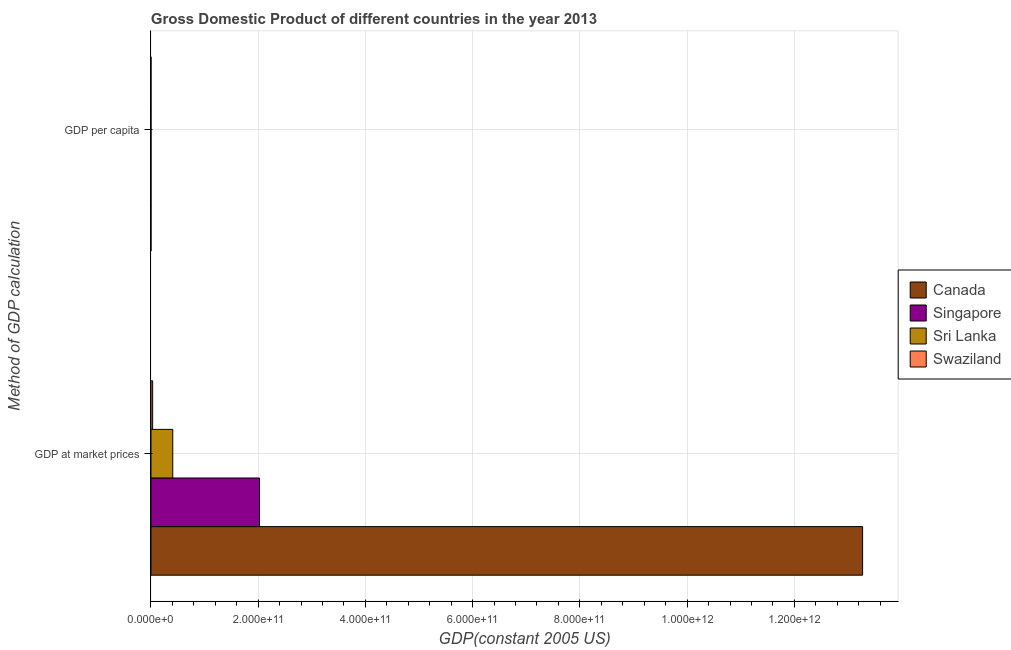How many groups of bars are there?
Your response must be concise. 2. Are the number of bars per tick equal to the number of legend labels?
Your answer should be compact. Yes. How many bars are there on the 1st tick from the top?
Offer a very short reply. 4. What is the label of the 1st group of bars from the top?
Ensure brevity in your answer.  GDP per capita. What is the gdp at market prices in Singapore?
Offer a very short reply. 2.02e+11. Across all countries, what is the maximum gdp per capita?
Your answer should be very brief. 3.78e+04. Across all countries, what is the minimum gdp per capita?
Your response must be concise. 1986.09. In which country was the gdp at market prices maximum?
Your response must be concise. Canada. In which country was the gdp per capita minimum?
Provide a short and direct response. Sri Lanka. What is the total gdp per capita in the graph?
Keep it short and to the point. 7.97e+04. What is the difference between the gdp per capita in Sri Lanka and that in Swaziland?
Offer a terse response. -516.36. What is the difference between the gdp at market prices in Singapore and the gdp per capita in Canada?
Your response must be concise. 2.02e+11. What is the average gdp at market prices per country?
Make the answer very short. 3.93e+11. What is the difference between the gdp at market prices and gdp per capita in Sri Lanka?
Ensure brevity in your answer.  4.07e+1. What is the ratio of the gdp per capita in Singapore to that in Canada?
Your answer should be very brief. 0.99. Is the gdp per capita in Sri Lanka less than that in Swaziland?
Offer a very short reply. Yes. What does the 2nd bar from the top in GDP at market prices represents?
Ensure brevity in your answer.  Sri Lanka. What does the 4th bar from the bottom in GDP at market prices represents?
Ensure brevity in your answer.  Swaziland. How many bars are there?
Offer a very short reply. 8. What is the difference between two consecutive major ticks on the X-axis?
Provide a succinct answer. 2.00e+11. Are the values on the major ticks of X-axis written in scientific E-notation?
Offer a terse response. Yes. Does the graph contain grids?
Offer a very short reply. Yes. How many legend labels are there?
Ensure brevity in your answer.  4. What is the title of the graph?
Ensure brevity in your answer.  Gross Domestic Product of different countries in the year 2013. Does "West Bank and Gaza" appear as one of the legend labels in the graph?
Your answer should be very brief. No. What is the label or title of the X-axis?
Keep it short and to the point. GDP(constant 2005 US). What is the label or title of the Y-axis?
Provide a succinct answer. Method of GDP calculation. What is the GDP(constant 2005 US) of Canada in GDP at market prices?
Keep it short and to the point. 1.33e+12. What is the GDP(constant 2005 US) in Singapore in GDP at market prices?
Offer a terse response. 2.02e+11. What is the GDP(constant 2005 US) of Sri Lanka in GDP at market prices?
Your answer should be compact. 4.07e+1. What is the GDP(constant 2005 US) in Swaziland in GDP at market prices?
Offer a terse response. 3.13e+09. What is the GDP(constant 2005 US) of Canada in GDP per capita?
Ensure brevity in your answer.  3.78e+04. What is the GDP(constant 2005 US) of Singapore in GDP per capita?
Provide a short and direct response. 3.75e+04. What is the GDP(constant 2005 US) in Sri Lanka in GDP per capita?
Provide a succinct answer. 1986.09. What is the GDP(constant 2005 US) of Swaziland in GDP per capita?
Give a very brief answer. 2502.46. Across all Method of GDP calculation, what is the maximum GDP(constant 2005 US) in Canada?
Make the answer very short. 1.33e+12. Across all Method of GDP calculation, what is the maximum GDP(constant 2005 US) in Singapore?
Give a very brief answer. 2.02e+11. Across all Method of GDP calculation, what is the maximum GDP(constant 2005 US) of Sri Lanka?
Offer a very short reply. 4.07e+1. Across all Method of GDP calculation, what is the maximum GDP(constant 2005 US) in Swaziland?
Your answer should be compact. 3.13e+09. Across all Method of GDP calculation, what is the minimum GDP(constant 2005 US) of Canada?
Offer a terse response. 3.78e+04. Across all Method of GDP calculation, what is the minimum GDP(constant 2005 US) in Singapore?
Your answer should be very brief. 3.75e+04. Across all Method of GDP calculation, what is the minimum GDP(constant 2005 US) in Sri Lanka?
Offer a very short reply. 1986.09. Across all Method of GDP calculation, what is the minimum GDP(constant 2005 US) of Swaziland?
Keep it short and to the point. 2502.46. What is the total GDP(constant 2005 US) in Canada in the graph?
Provide a succinct answer. 1.33e+12. What is the total GDP(constant 2005 US) of Singapore in the graph?
Provide a short and direct response. 2.02e+11. What is the total GDP(constant 2005 US) of Sri Lanka in the graph?
Your answer should be very brief. 4.07e+1. What is the total GDP(constant 2005 US) in Swaziland in the graph?
Make the answer very short. 3.13e+09. What is the difference between the GDP(constant 2005 US) in Canada in GDP at market prices and that in GDP per capita?
Keep it short and to the point. 1.33e+12. What is the difference between the GDP(constant 2005 US) in Singapore in GDP at market prices and that in GDP per capita?
Your answer should be compact. 2.02e+11. What is the difference between the GDP(constant 2005 US) of Sri Lanka in GDP at market prices and that in GDP per capita?
Your answer should be very brief. 4.07e+1. What is the difference between the GDP(constant 2005 US) of Swaziland in GDP at market prices and that in GDP per capita?
Offer a terse response. 3.13e+09. What is the difference between the GDP(constant 2005 US) in Canada in GDP at market prices and the GDP(constant 2005 US) in Singapore in GDP per capita?
Your answer should be very brief. 1.33e+12. What is the difference between the GDP(constant 2005 US) of Canada in GDP at market prices and the GDP(constant 2005 US) of Sri Lanka in GDP per capita?
Provide a short and direct response. 1.33e+12. What is the difference between the GDP(constant 2005 US) of Canada in GDP at market prices and the GDP(constant 2005 US) of Swaziland in GDP per capita?
Offer a very short reply. 1.33e+12. What is the difference between the GDP(constant 2005 US) of Singapore in GDP at market prices and the GDP(constant 2005 US) of Sri Lanka in GDP per capita?
Provide a short and direct response. 2.02e+11. What is the difference between the GDP(constant 2005 US) of Singapore in GDP at market prices and the GDP(constant 2005 US) of Swaziland in GDP per capita?
Provide a succinct answer. 2.02e+11. What is the difference between the GDP(constant 2005 US) in Sri Lanka in GDP at market prices and the GDP(constant 2005 US) in Swaziland in GDP per capita?
Your answer should be compact. 4.07e+1. What is the average GDP(constant 2005 US) in Canada per Method of GDP calculation?
Offer a very short reply. 6.64e+11. What is the average GDP(constant 2005 US) in Singapore per Method of GDP calculation?
Your response must be concise. 1.01e+11. What is the average GDP(constant 2005 US) in Sri Lanka per Method of GDP calculation?
Offer a very short reply. 2.03e+1. What is the average GDP(constant 2005 US) of Swaziland per Method of GDP calculation?
Your answer should be compact. 1.56e+09. What is the difference between the GDP(constant 2005 US) of Canada and GDP(constant 2005 US) of Singapore in GDP at market prices?
Make the answer very short. 1.12e+12. What is the difference between the GDP(constant 2005 US) of Canada and GDP(constant 2005 US) of Sri Lanka in GDP at market prices?
Keep it short and to the point. 1.29e+12. What is the difference between the GDP(constant 2005 US) in Canada and GDP(constant 2005 US) in Swaziland in GDP at market prices?
Your answer should be compact. 1.32e+12. What is the difference between the GDP(constant 2005 US) in Singapore and GDP(constant 2005 US) in Sri Lanka in GDP at market prices?
Provide a short and direct response. 1.62e+11. What is the difference between the GDP(constant 2005 US) in Singapore and GDP(constant 2005 US) in Swaziland in GDP at market prices?
Offer a very short reply. 1.99e+11. What is the difference between the GDP(constant 2005 US) of Sri Lanka and GDP(constant 2005 US) of Swaziland in GDP at market prices?
Your answer should be very brief. 3.76e+1. What is the difference between the GDP(constant 2005 US) of Canada and GDP(constant 2005 US) of Singapore in GDP per capita?
Offer a terse response. 262.61. What is the difference between the GDP(constant 2005 US) of Canada and GDP(constant 2005 US) of Sri Lanka in GDP per capita?
Keep it short and to the point. 3.58e+04. What is the difference between the GDP(constant 2005 US) in Canada and GDP(constant 2005 US) in Swaziland in GDP per capita?
Offer a terse response. 3.53e+04. What is the difference between the GDP(constant 2005 US) in Singapore and GDP(constant 2005 US) in Sri Lanka in GDP per capita?
Keep it short and to the point. 3.55e+04. What is the difference between the GDP(constant 2005 US) of Singapore and GDP(constant 2005 US) of Swaziland in GDP per capita?
Offer a very short reply. 3.50e+04. What is the difference between the GDP(constant 2005 US) of Sri Lanka and GDP(constant 2005 US) of Swaziland in GDP per capita?
Provide a succinct answer. -516.36. What is the ratio of the GDP(constant 2005 US) of Canada in GDP at market prices to that in GDP per capita?
Keep it short and to the point. 3.52e+07. What is the ratio of the GDP(constant 2005 US) of Singapore in GDP at market prices to that in GDP per capita?
Your response must be concise. 5.40e+06. What is the ratio of the GDP(constant 2005 US) in Sri Lanka in GDP at market prices to that in GDP per capita?
Provide a succinct answer. 2.05e+07. What is the ratio of the GDP(constant 2005 US) in Swaziland in GDP at market prices to that in GDP per capita?
Give a very brief answer. 1.25e+06. What is the difference between the highest and the second highest GDP(constant 2005 US) of Canada?
Your response must be concise. 1.33e+12. What is the difference between the highest and the second highest GDP(constant 2005 US) in Singapore?
Offer a very short reply. 2.02e+11. What is the difference between the highest and the second highest GDP(constant 2005 US) of Sri Lanka?
Keep it short and to the point. 4.07e+1. What is the difference between the highest and the second highest GDP(constant 2005 US) in Swaziland?
Keep it short and to the point. 3.13e+09. What is the difference between the highest and the lowest GDP(constant 2005 US) in Canada?
Give a very brief answer. 1.33e+12. What is the difference between the highest and the lowest GDP(constant 2005 US) of Singapore?
Keep it short and to the point. 2.02e+11. What is the difference between the highest and the lowest GDP(constant 2005 US) in Sri Lanka?
Your answer should be compact. 4.07e+1. What is the difference between the highest and the lowest GDP(constant 2005 US) of Swaziland?
Provide a succinct answer. 3.13e+09. 